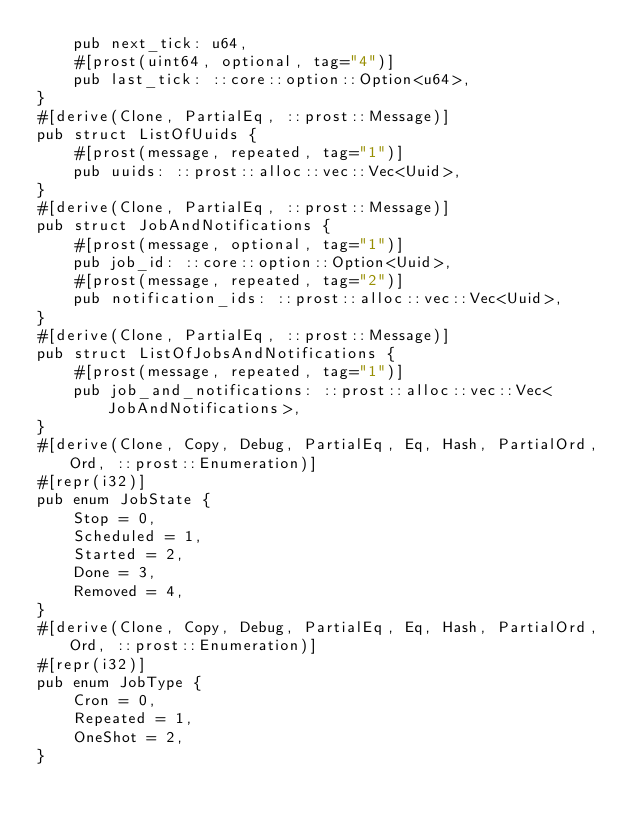Convert code to text. <code><loc_0><loc_0><loc_500><loc_500><_Rust_>    pub next_tick: u64,
    #[prost(uint64, optional, tag="4")]
    pub last_tick: ::core::option::Option<u64>,
}
#[derive(Clone, PartialEq, ::prost::Message)]
pub struct ListOfUuids {
    #[prost(message, repeated, tag="1")]
    pub uuids: ::prost::alloc::vec::Vec<Uuid>,
}
#[derive(Clone, PartialEq, ::prost::Message)]
pub struct JobAndNotifications {
    #[prost(message, optional, tag="1")]
    pub job_id: ::core::option::Option<Uuid>,
    #[prost(message, repeated, tag="2")]
    pub notification_ids: ::prost::alloc::vec::Vec<Uuid>,
}
#[derive(Clone, PartialEq, ::prost::Message)]
pub struct ListOfJobsAndNotifications {
    #[prost(message, repeated, tag="1")]
    pub job_and_notifications: ::prost::alloc::vec::Vec<JobAndNotifications>,
}
#[derive(Clone, Copy, Debug, PartialEq, Eq, Hash, PartialOrd, Ord, ::prost::Enumeration)]
#[repr(i32)]
pub enum JobState {
    Stop = 0,
    Scheduled = 1,
    Started = 2,
    Done = 3,
    Removed = 4,
}
#[derive(Clone, Copy, Debug, PartialEq, Eq, Hash, PartialOrd, Ord, ::prost::Enumeration)]
#[repr(i32)]
pub enum JobType {
    Cron = 0,
    Repeated = 1,
    OneShot = 2,
}
</code> 